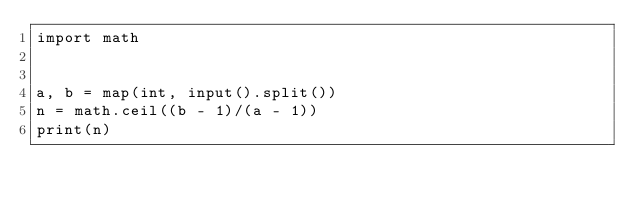Convert code to text. <code><loc_0><loc_0><loc_500><loc_500><_Python_>import math


a, b = map(int, input().split())
n = math.ceil((b - 1)/(a - 1))
print(n)
</code> 